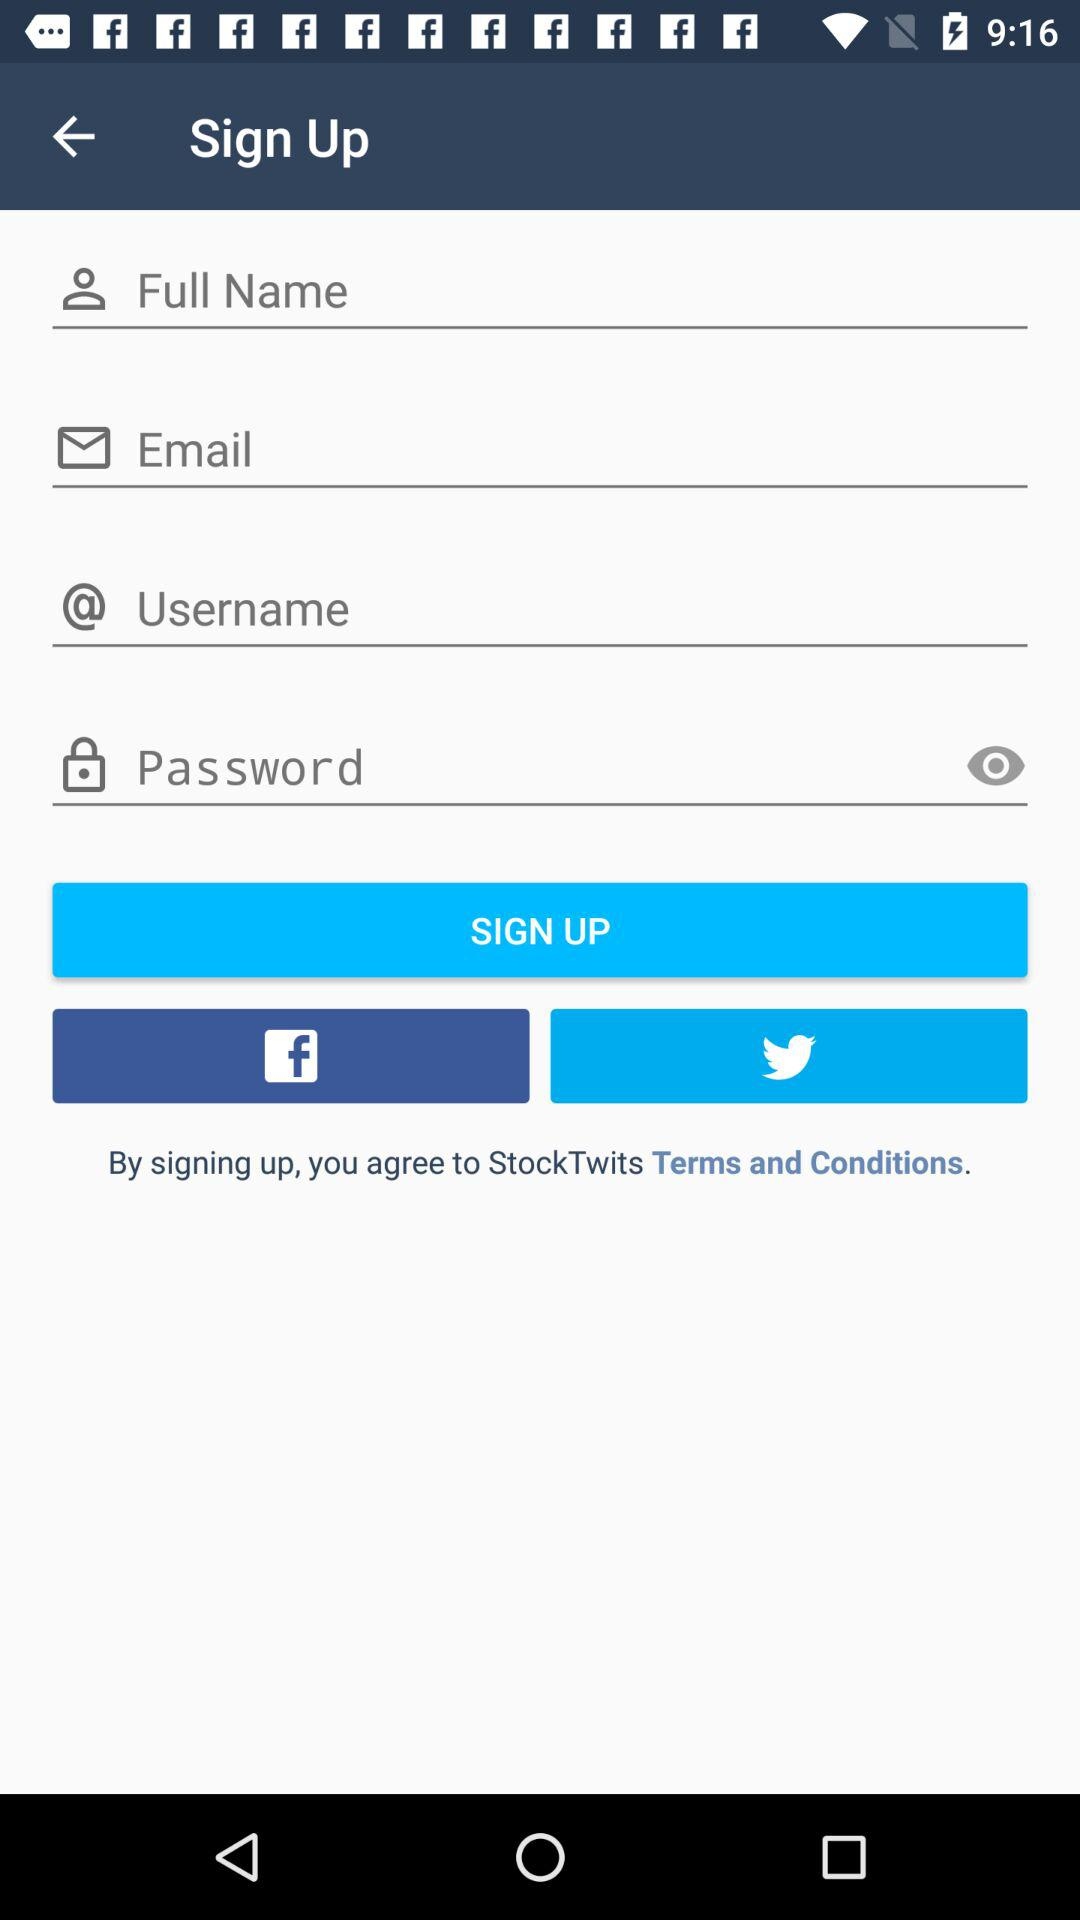How many text inputs are required to sign up?
Answer the question using a single word or phrase. 4 